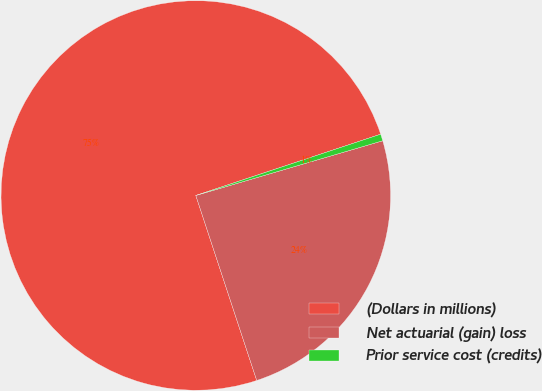Convert chart. <chart><loc_0><loc_0><loc_500><loc_500><pie_chart><fcel>(Dollars in millions)<fcel>Net actuarial (gain) loss<fcel>Prior service cost (credits)<nl><fcel>74.97%<fcel>24.47%<fcel>0.56%<nl></chart> 